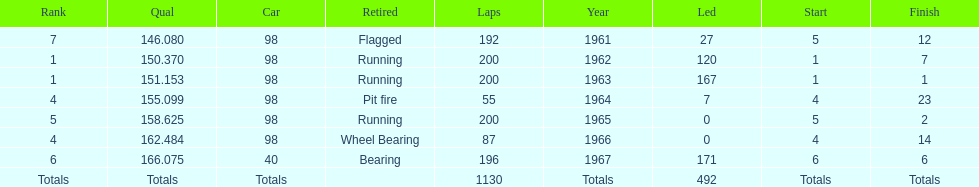What year(s) did parnelli finish at least 4th or better? 1963, 1965. 